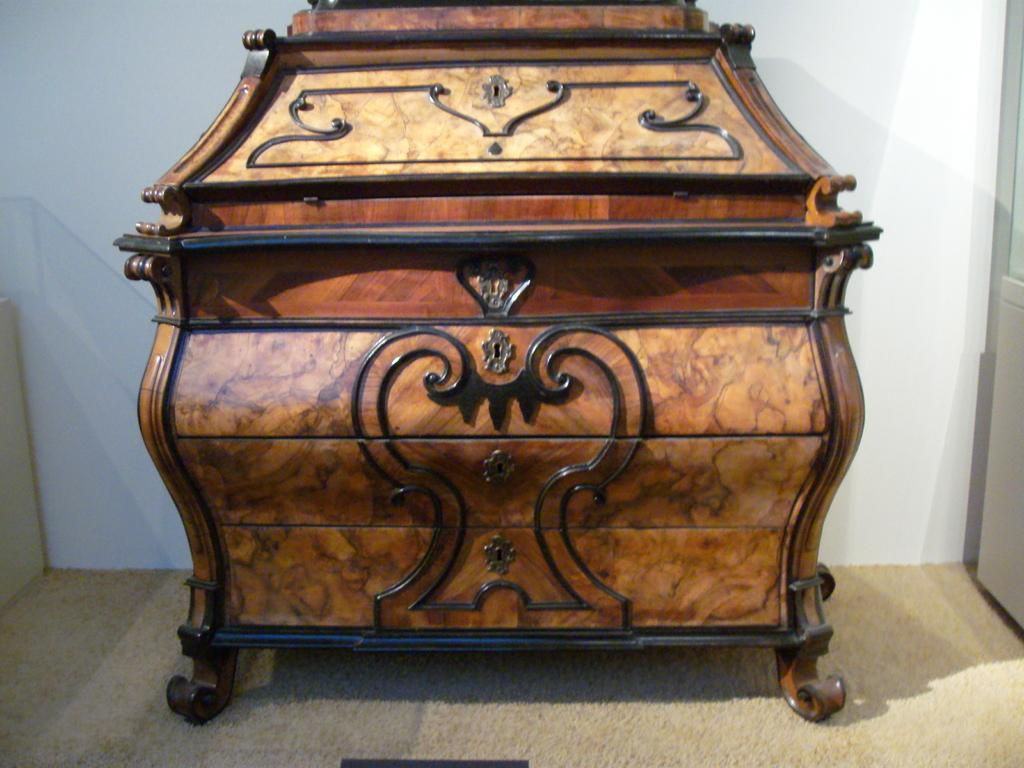What object is the main focus of the image? There is a wooden box in the image. What can be seen behind the wooden box? There is a white color wall in the background of the image. Are there any clouds visible in the image? No, there are no clouds visible in the image; it only features a wooden box and a white color wall in the background. 